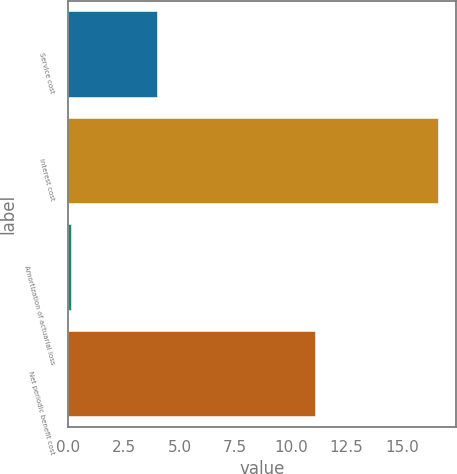Convert chart to OTSL. <chart><loc_0><loc_0><loc_500><loc_500><bar_chart><fcel>Service cost<fcel>Interest cost<fcel>Amortization of actuarial loss<fcel>Net periodic benefit cost<nl><fcel>4<fcel>16.6<fcel>0.1<fcel>11.1<nl></chart> 